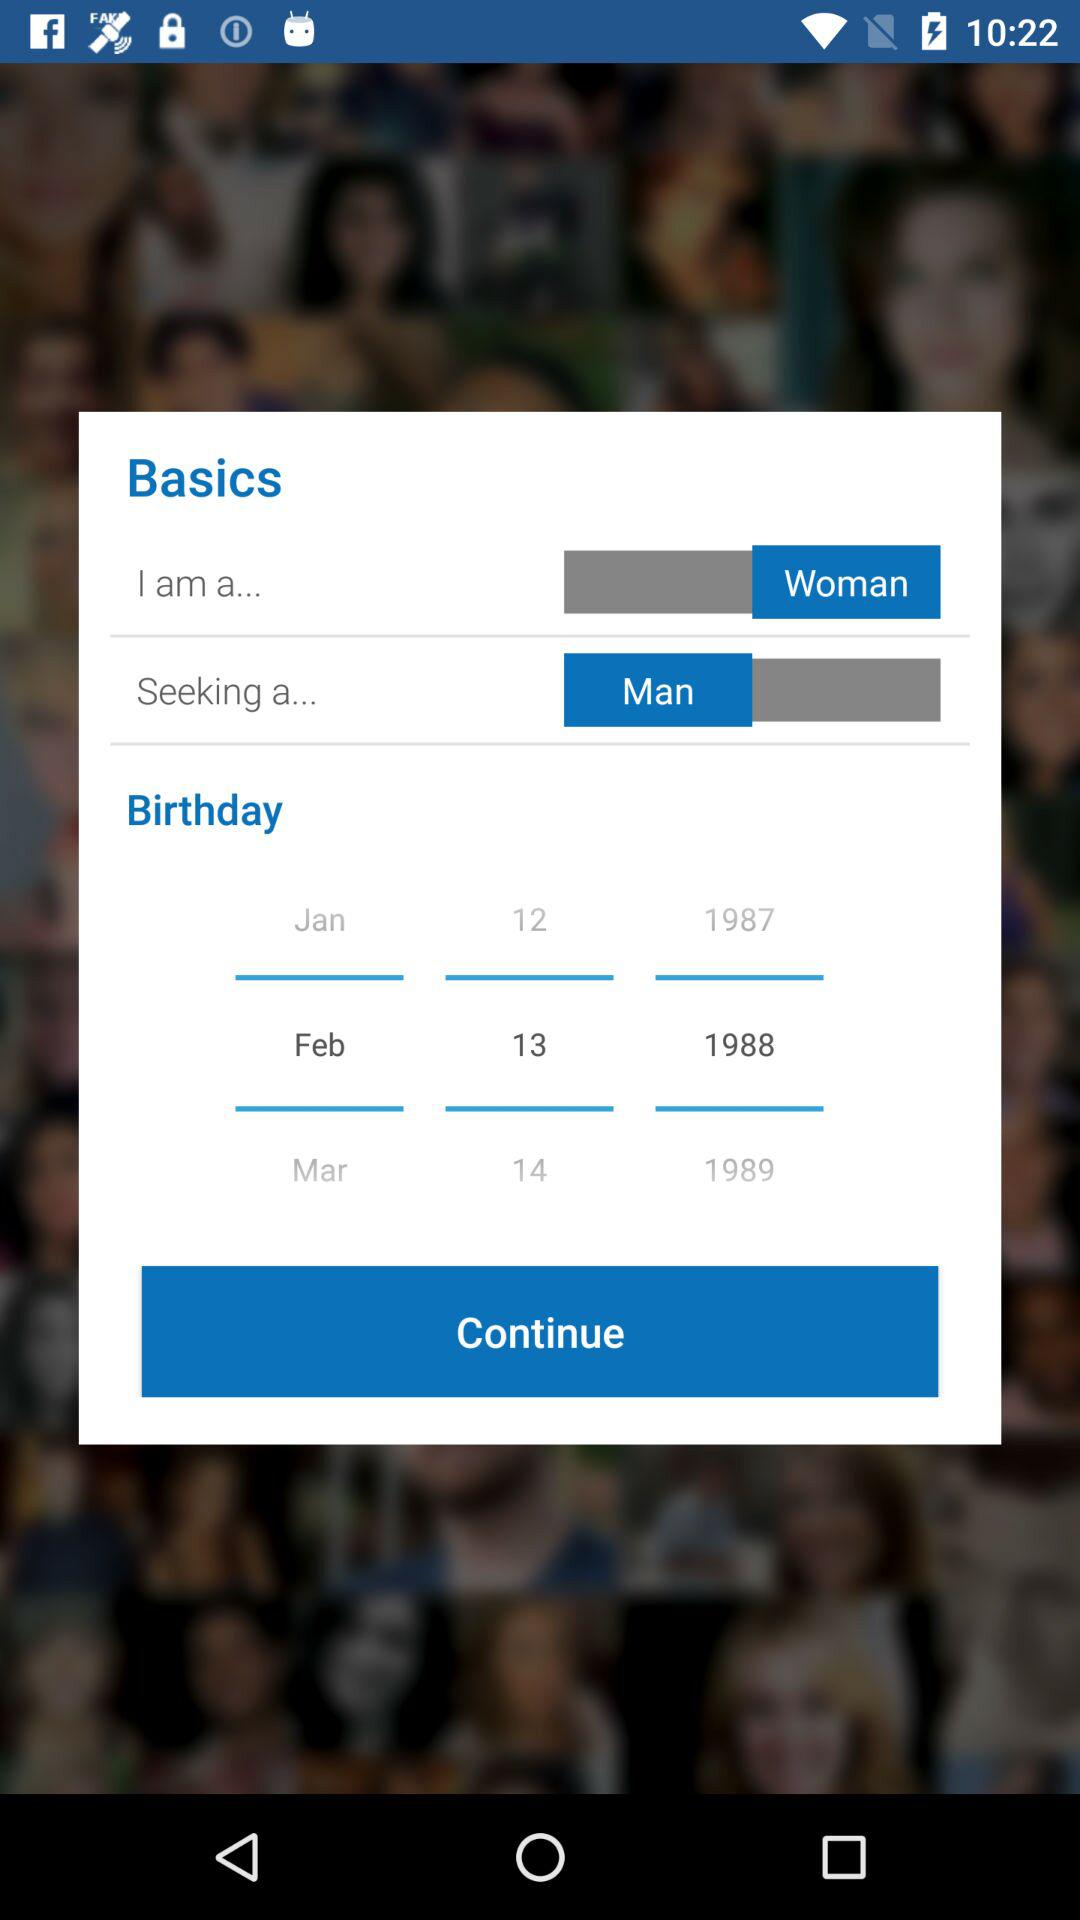What is the user seeeking? The user is seeking a man. 